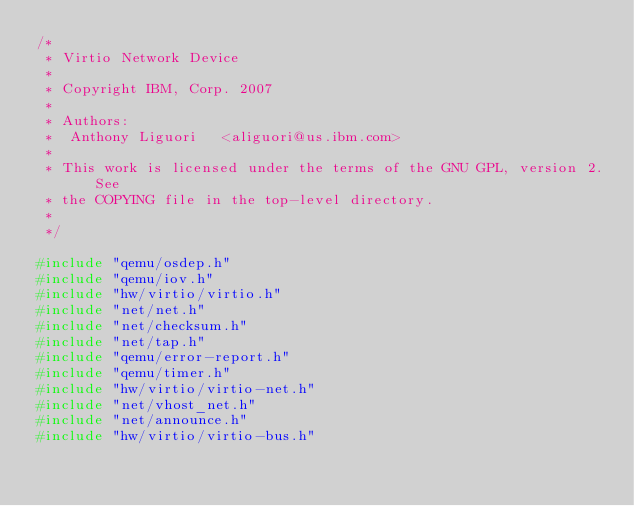<code> <loc_0><loc_0><loc_500><loc_500><_C_>/*
 * Virtio Network Device
 *
 * Copyright IBM, Corp. 2007
 *
 * Authors:
 *  Anthony Liguori   <aliguori@us.ibm.com>
 *
 * This work is licensed under the terms of the GNU GPL, version 2.  See
 * the COPYING file in the top-level directory.
 *
 */

#include "qemu/osdep.h"
#include "qemu/iov.h"
#include "hw/virtio/virtio.h"
#include "net/net.h"
#include "net/checksum.h"
#include "net/tap.h"
#include "qemu/error-report.h"
#include "qemu/timer.h"
#include "hw/virtio/virtio-net.h"
#include "net/vhost_net.h"
#include "net/announce.h"
#include "hw/virtio/virtio-bus.h"</code> 